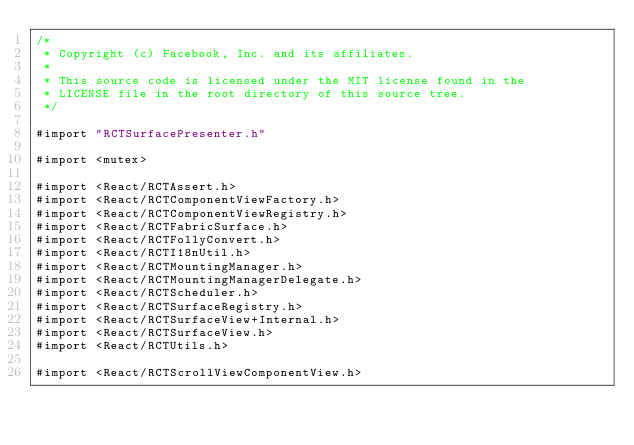<code> <loc_0><loc_0><loc_500><loc_500><_ObjectiveC_>/*
 * Copyright (c) Facebook, Inc. and its affiliates.
 *
 * This source code is licensed under the MIT license found in the
 * LICENSE file in the root directory of this source tree.
 */

#import "RCTSurfacePresenter.h"

#import <mutex>

#import <React/RCTAssert.h>
#import <React/RCTComponentViewFactory.h>
#import <React/RCTComponentViewRegistry.h>
#import <React/RCTFabricSurface.h>
#import <React/RCTFollyConvert.h>
#import <React/RCTI18nUtil.h>
#import <React/RCTMountingManager.h>
#import <React/RCTMountingManagerDelegate.h>
#import <React/RCTScheduler.h>
#import <React/RCTSurfaceRegistry.h>
#import <React/RCTSurfaceView+Internal.h>
#import <React/RCTSurfaceView.h>
#import <React/RCTUtils.h>

#import <React/RCTScrollViewComponentView.h>
</code> 